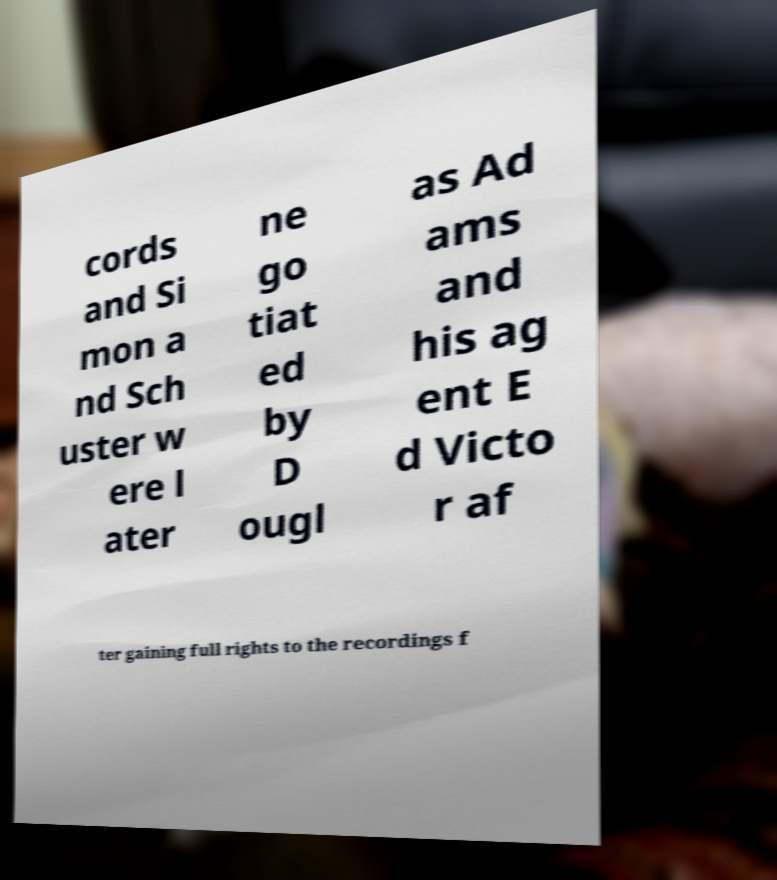What messages or text are displayed in this image? I need them in a readable, typed format. cords and Si mon a nd Sch uster w ere l ater ne go tiat ed by D ougl as Ad ams and his ag ent E d Victo r af ter gaining full rights to the recordings f 